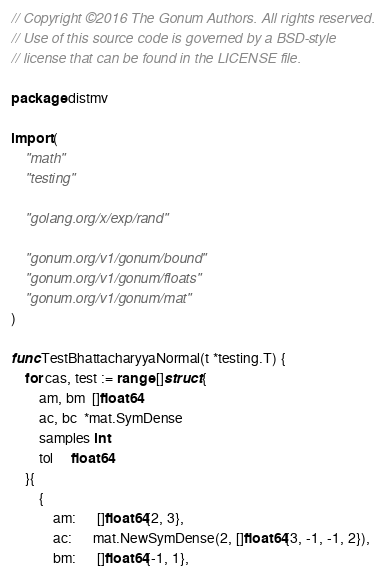<code> <loc_0><loc_0><loc_500><loc_500><_Go_>// Copyright ©2016 The Gonum Authors. All rights reserved.
// Use of this source code is governed by a BSD-style
// license that can be found in the LICENSE file.

package distmv

import (
	"math"
	"testing"

	"golang.org/x/exp/rand"

	"gonum.org/v1/gonum/bound"
	"gonum.org/v1/gonum/floats"
	"gonum.org/v1/gonum/mat"
)

func TestBhattacharyyaNormal(t *testing.T) {
	for cas, test := range []struct {
		am, bm  []float64
		ac, bc  *mat.SymDense
		samples int
		tol     float64
	}{
		{
			am:      []float64{2, 3},
			ac:      mat.NewSymDense(2, []float64{3, -1, -1, 2}),
			bm:      []float64{-1, 1},</code> 